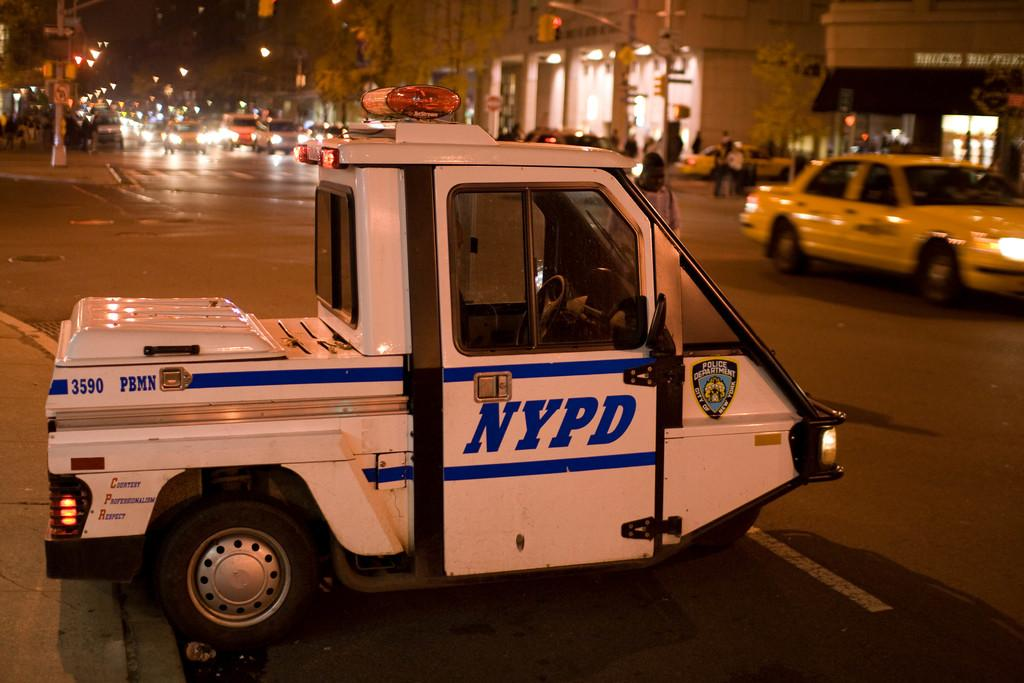Provide a one-sentence caption for the provided image. a vehicle that has NYPD written on it. 